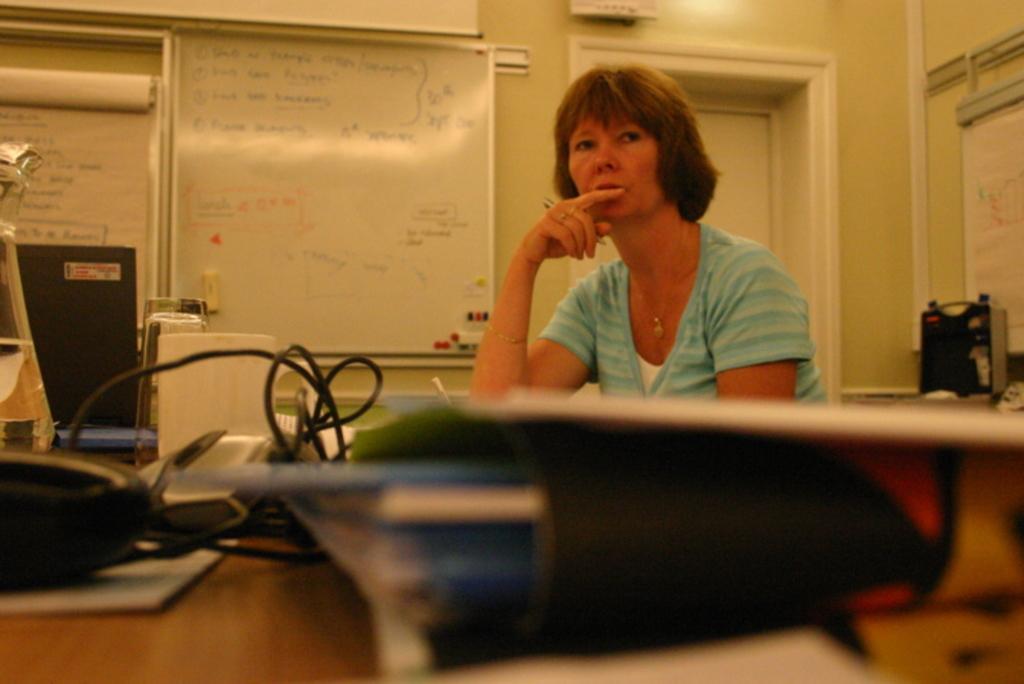How would you summarize this image in a sentence or two? In this image I can see the person wearing the white and blue color dress. On the table I can see the wires, files and some objects. In the back I can see the boards to the wall. 